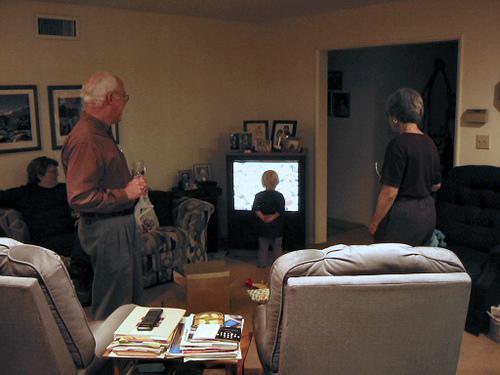How many lazyboy chairs are present?
Give a very brief answer. 3. How many people are standing while watching television?
Give a very brief answer. 0. 